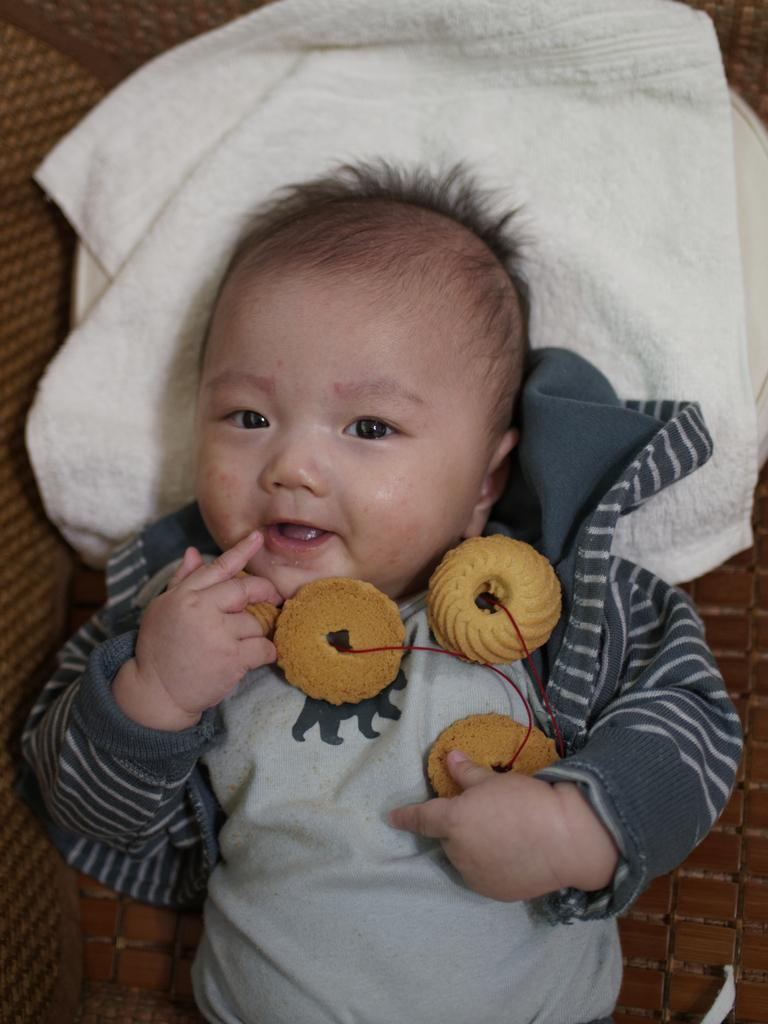What is the main subject of the image? There is a baby in the image. What is behind the baby? There is a cloth behind the baby. What can be seen on the baby? Cookies are present on the baby. What type of boat can be seen in the image? There is no boat present in the image. Can you describe the building in the background of the image? There is no building present in the image. 